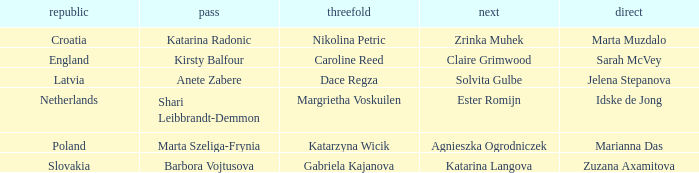Give me the full table as a dictionary. {'header': ['republic', 'pass', 'threefold', 'next', 'direct'], 'rows': [['Croatia', 'Katarina Radonic', 'Nikolina Petric', 'Zrinka Muhek', 'Marta Muzdalo'], ['England', 'Kirsty Balfour', 'Caroline Reed', 'Claire Grimwood', 'Sarah McVey'], ['Latvia', 'Anete Zabere', 'Dace Regza', 'Solvita Gulbe', 'Jelena Stepanova'], ['Netherlands', 'Shari Leibbrandt-Demmon', 'Margrietha Voskuilen', 'Ester Romijn', 'Idske de Jong'], ['Poland', 'Marta Szeliga-Frynia', 'Katarzyna Wicik', 'Agnieszka Ogrodniczek', 'Marianna Das'], ['Slovakia', 'Barbora Vojtusova', 'Gabriela Kajanova', 'Katarina Langova', 'Zuzana Axamitova']]} Which skip has Zrinka Muhek as Second? Katarina Radonic. 